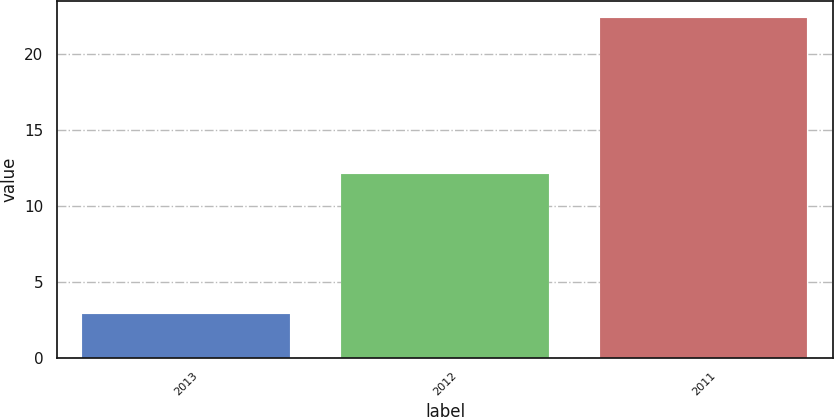<chart> <loc_0><loc_0><loc_500><loc_500><bar_chart><fcel>2013<fcel>2012<fcel>2011<nl><fcel>2.9<fcel>12.1<fcel>22.4<nl></chart> 